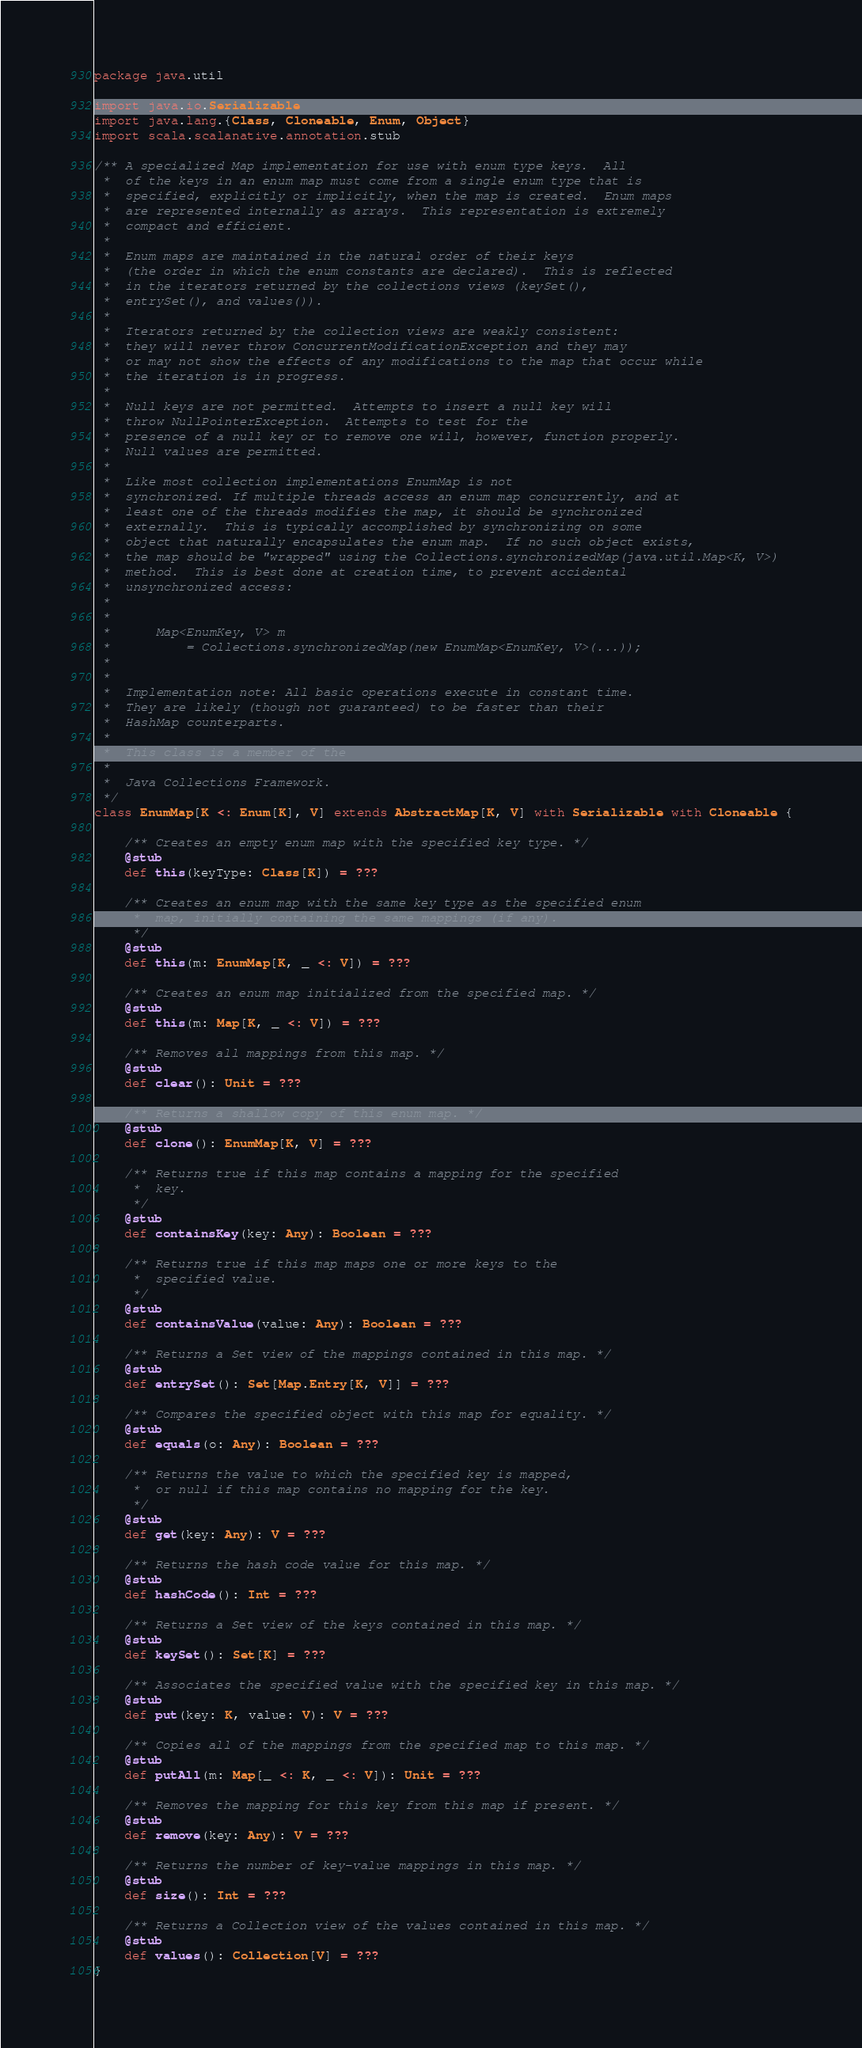<code> <loc_0><loc_0><loc_500><loc_500><_Scala_>package java.util

import java.io.Serializable
import java.lang.{Class, Cloneable, Enum, Object}
import scala.scalanative.annotation.stub

/** A specialized Map implementation for use with enum type keys.  All
 *  of the keys in an enum map must come from a single enum type that is
 *  specified, explicitly or implicitly, when the map is created.  Enum maps
 *  are represented internally as arrays.  This representation is extremely
 *  compact and efficient.
 * 
 *  Enum maps are maintained in the natural order of their keys
 *  (the order in which the enum constants are declared).  This is reflected
 *  in the iterators returned by the collections views (keySet(),
 *  entrySet(), and values()).
 * 
 *  Iterators returned by the collection views are weakly consistent:
 *  they will never throw ConcurrentModificationException and they may
 *  or may not show the effects of any modifications to the map that occur while
 *  the iteration is in progress.
 * 
 *  Null keys are not permitted.  Attempts to insert a null key will
 *  throw NullPointerException.  Attempts to test for the
 *  presence of a null key or to remove one will, however, function properly.
 *  Null values are permitted.
 * 
 *  Like most collection implementations EnumMap is not
 *  synchronized. If multiple threads access an enum map concurrently, and at
 *  least one of the threads modifies the map, it should be synchronized
 *  externally.  This is typically accomplished by synchronizing on some
 *  object that naturally encapsulates the enum map.  If no such object exists,
 *  the map should be "wrapped" using the Collections.synchronizedMap(java.util.Map<K, V>)
 *  method.  This is best done at creation time, to prevent accidental
 *  unsynchronized access:
 * 
 *  
 *      Map<EnumKey, V> m
 *          = Collections.synchronizedMap(new EnumMap<EnumKey, V>(...));
 *  
 * 
 *  Implementation note: All basic operations execute in constant time.
 *  They are likely (though not guaranteed) to be faster than their
 *  HashMap counterparts.
 * 
 *  This class is a member of the
 *  
 *  Java Collections Framework.
 */
class EnumMap[K <: Enum[K], V] extends AbstractMap[K, V] with Serializable with Cloneable {

    /** Creates an empty enum map with the specified key type. */
    @stub
    def this(keyType: Class[K]) = ???

    /** Creates an enum map with the same key type as the specified enum
     *  map, initially containing the same mappings (if any).
     */
    @stub
    def this(m: EnumMap[K, _ <: V]) = ???

    /** Creates an enum map initialized from the specified map. */
    @stub
    def this(m: Map[K, _ <: V]) = ???

    /** Removes all mappings from this map. */
    @stub
    def clear(): Unit = ???

    /** Returns a shallow copy of this enum map. */
    @stub
    def clone(): EnumMap[K, V] = ???

    /** Returns true if this map contains a mapping for the specified
     *  key.
     */
    @stub
    def containsKey(key: Any): Boolean = ???

    /** Returns true if this map maps one or more keys to the
     *  specified value.
     */
    @stub
    def containsValue(value: Any): Boolean = ???

    /** Returns a Set view of the mappings contained in this map. */
    @stub
    def entrySet(): Set[Map.Entry[K, V]] = ???

    /** Compares the specified object with this map for equality. */
    @stub
    def equals(o: Any): Boolean = ???

    /** Returns the value to which the specified key is mapped,
     *  or null if this map contains no mapping for the key.
     */
    @stub
    def get(key: Any): V = ???

    /** Returns the hash code value for this map. */
    @stub
    def hashCode(): Int = ???

    /** Returns a Set view of the keys contained in this map. */
    @stub
    def keySet(): Set[K] = ???

    /** Associates the specified value with the specified key in this map. */
    @stub
    def put(key: K, value: V): V = ???

    /** Copies all of the mappings from the specified map to this map. */
    @stub
    def putAll(m: Map[_ <: K, _ <: V]): Unit = ???

    /** Removes the mapping for this key from this map if present. */
    @stub
    def remove(key: Any): V = ???

    /** Returns the number of key-value mappings in this map. */
    @stub
    def size(): Int = ???

    /** Returns a Collection view of the values contained in this map. */
    @stub
    def values(): Collection[V] = ???
}
</code> 